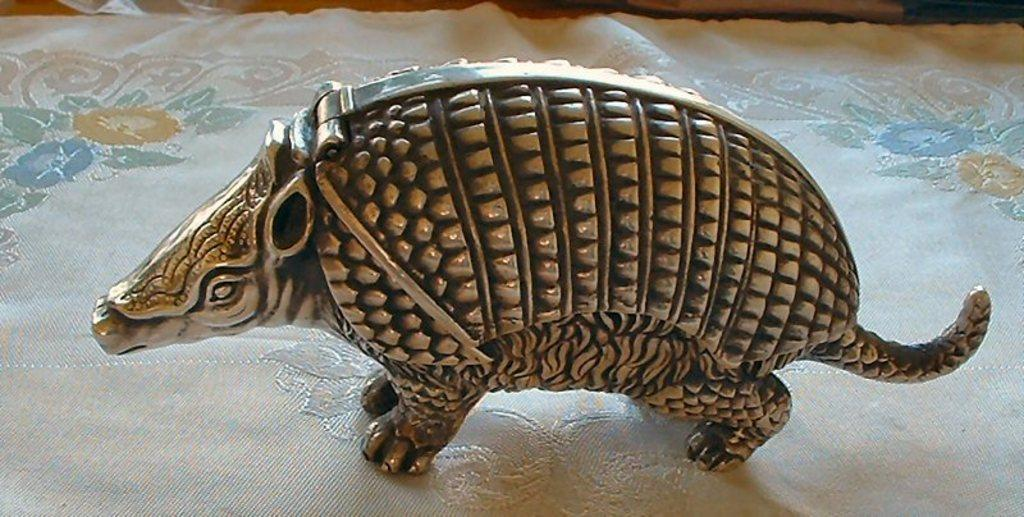What is the main subject of the image? There is a statue of an animal in the image. What is the statue placed on? The statue is on a cloth. Is there any blood visible on the statue in the image? No, there is no blood visible on the statue in the image. Is there a fireman present in the image? No, there is no fireman present in the image. 